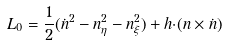<formula> <loc_0><loc_0><loc_500><loc_500>L _ { 0 } = \frac { 1 } { 2 } ( \dot { n } ^ { 2 } - { n } ^ { 2 } _ { \eta } - { n } ^ { 2 } _ { \xi } ) + { h } { \cdot } ( { n } \times \dot { n } )</formula> 